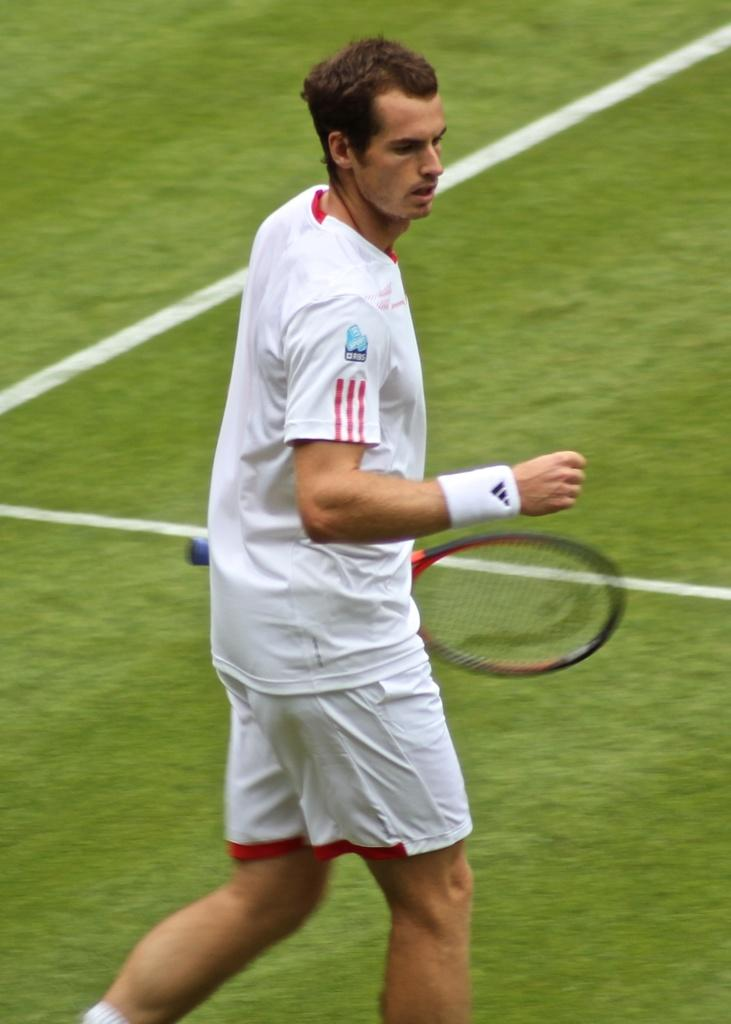Where was the image taken? The image was taken in a stadium. Can you describe the person in the image? There is a man in the image, and he is wearing a white shirt. What is the man holding in the image? The man is holding a racket. What is the color of the grass visible at the bottom of the image? The grass is green. Can you tell me how many cannons are visible in the image? There are no cannons present in the image. What type of watch is the man wearing in the image? The man is not wearing a watch in the image. 